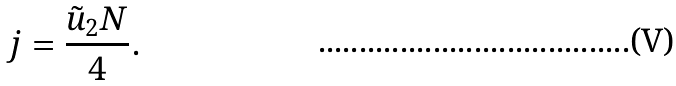<formula> <loc_0><loc_0><loc_500><loc_500>j = \frac { \tilde { u } _ { 2 } N } { 4 } .</formula> 